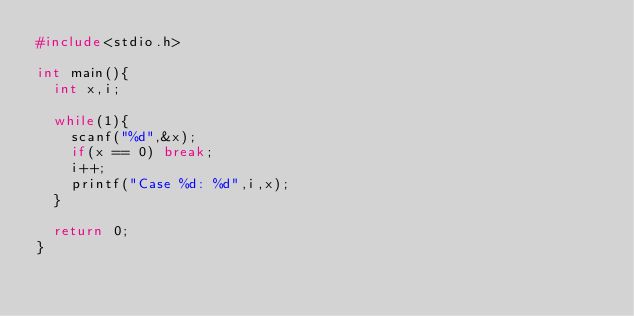<code> <loc_0><loc_0><loc_500><loc_500><_C_>#include<stdio.h>
   
int main(){
  int x,i;

  while(1){
    scanf("%d",&x);
    if(x == 0) break;
    i++;
    printf("Case %d: %d",i,x);
  }

  return 0;
}
</code> 